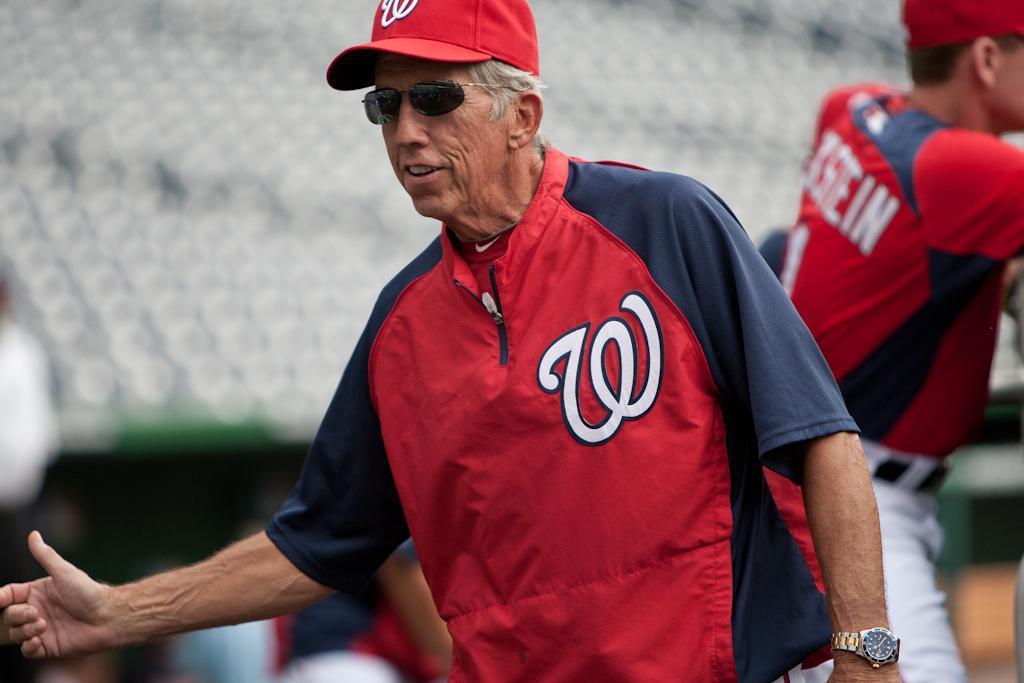Please provide a concise description of this image. In this image there is an old man who is wearing the red jacket and red cap is raising his hand. In the background there is another man who is standing. 